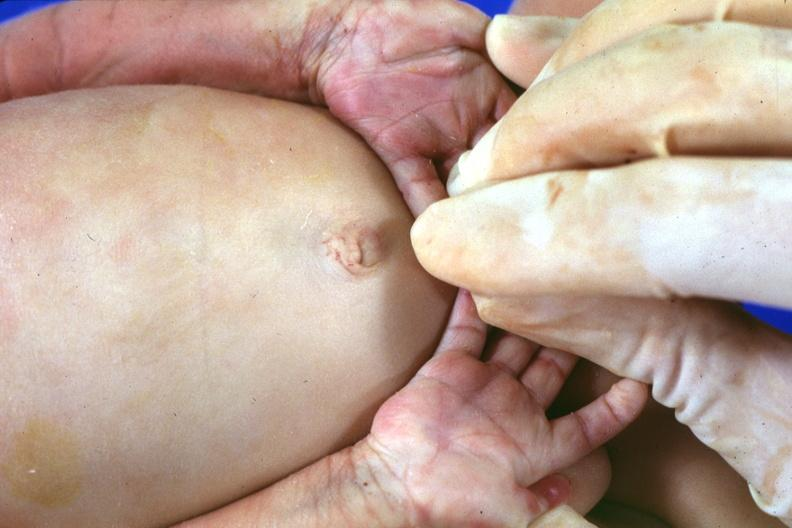what are present?
Answer the question using a single word or phrase. Extremities 